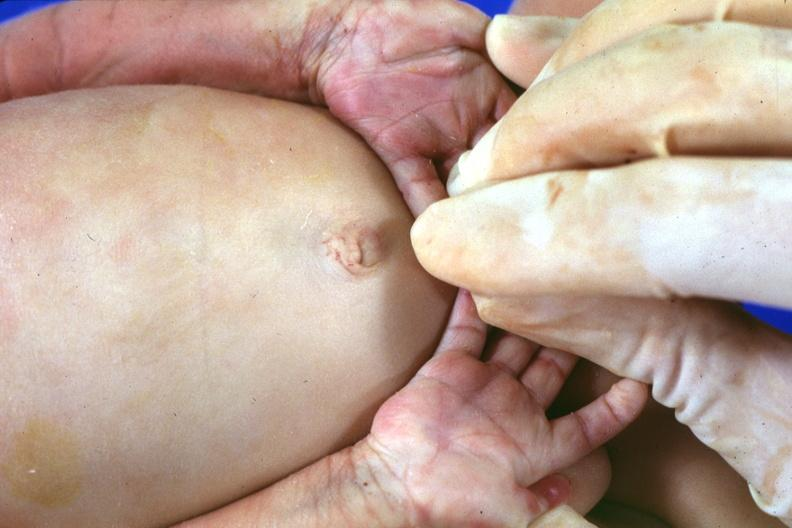what are present?
Answer the question using a single word or phrase. Extremities 